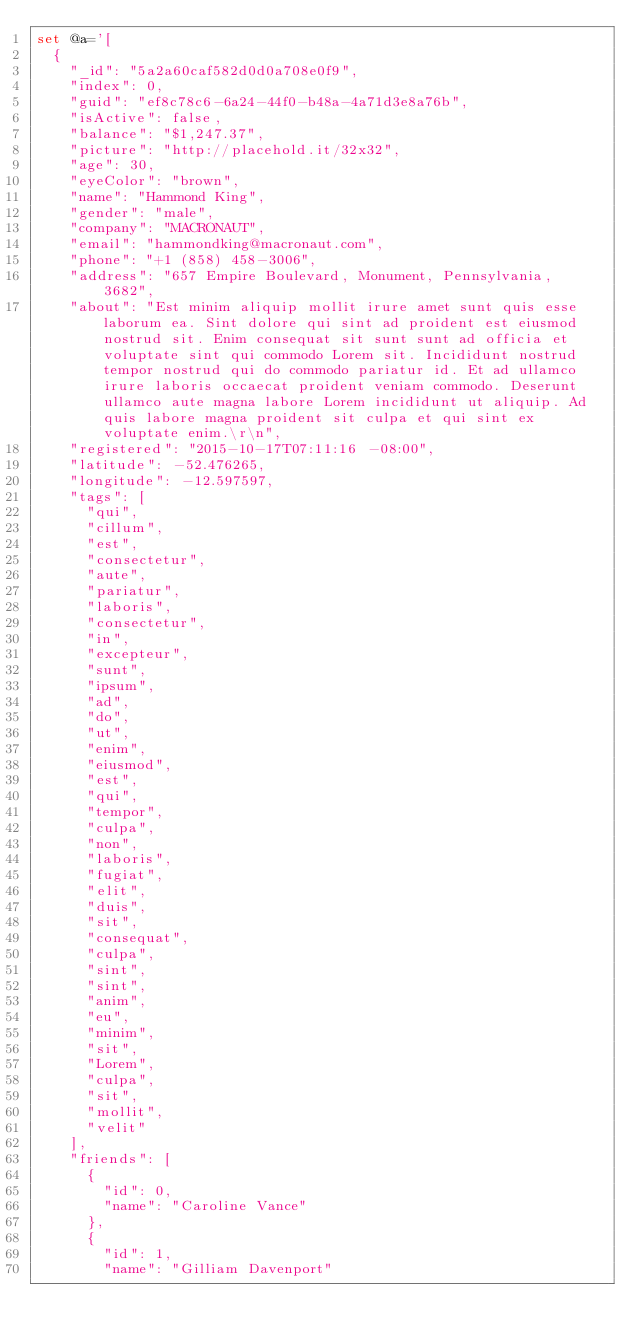Convert code to text. <code><loc_0><loc_0><loc_500><loc_500><_SQL_>set @a='[
  {
    "_id": "5a2a60caf582d0d0a708e0f9",
    "index": 0,
    "guid": "ef8c78c6-6a24-44f0-b48a-4a71d3e8a76b",
    "isActive": false,
    "balance": "$1,247.37",
    "picture": "http://placehold.it/32x32",
    "age": 30,
    "eyeColor": "brown",
    "name": "Hammond King",
    "gender": "male",
    "company": "MACRONAUT",
    "email": "hammondking@macronaut.com",
    "phone": "+1 (858) 458-3006",
    "address": "657 Empire Boulevard, Monument, Pennsylvania, 3682",
    "about": "Est minim aliquip mollit irure amet sunt quis esse laborum ea. Sint dolore qui sint ad proident est eiusmod nostrud sit. Enim consequat sit sunt sunt ad officia et voluptate sint qui commodo Lorem sit. Incididunt nostrud tempor nostrud qui do commodo pariatur id. Et ad ullamco irure laboris occaecat proident veniam commodo. Deserunt ullamco aute magna labore Lorem incididunt ut aliquip. Ad quis labore magna proident sit culpa et qui sint ex voluptate enim.\r\n",
    "registered": "2015-10-17T07:11:16 -08:00",
    "latitude": -52.476265,
    "longitude": -12.597597,
    "tags": [
      "qui",
      "cillum",
      "est",
      "consectetur",
      "aute",
      "pariatur",
      "laboris",
      "consectetur",
      "in",
      "excepteur",
      "sunt",
      "ipsum",
      "ad",
      "do",
      "ut",
      "enim",
      "eiusmod",
      "est",
      "qui",
      "tempor",
      "culpa",
      "non",
      "laboris",
      "fugiat",
      "elit",
      "duis",
      "sit",
      "consequat",
      "culpa",
      "sint",
      "sint",
      "anim",
      "eu",
      "minim",
      "sit",
      "Lorem",
      "culpa",
      "sit",
      "mollit",
      "velit"
    ],
    "friends": [
      {
        "id": 0,
        "name": "Caroline Vance"
      },
      {
        "id": 1,
        "name": "Gilliam Davenport"</code> 